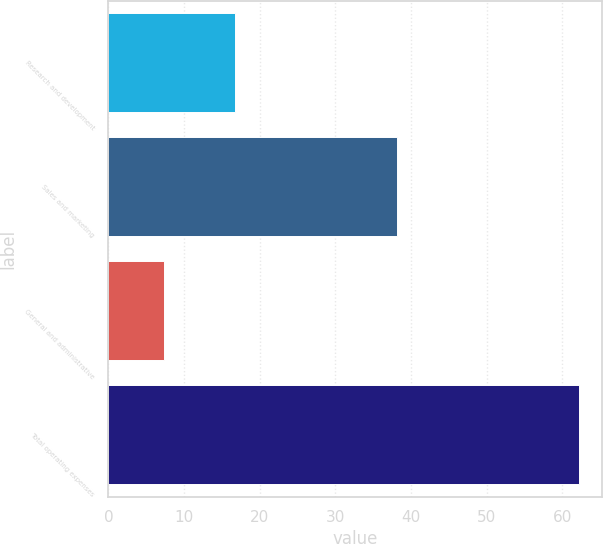Convert chart. <chart><loc_0><loc_0><loc_500><loc_500><bar_chart><fcel>Research and development<fcel>Sales and marketing<fcel>General and administrative<fcel>Total operating expenses<nl><fcel>16.7<fcel>38.2<fcel>7.3<fcel>62.2<nl></chart> 